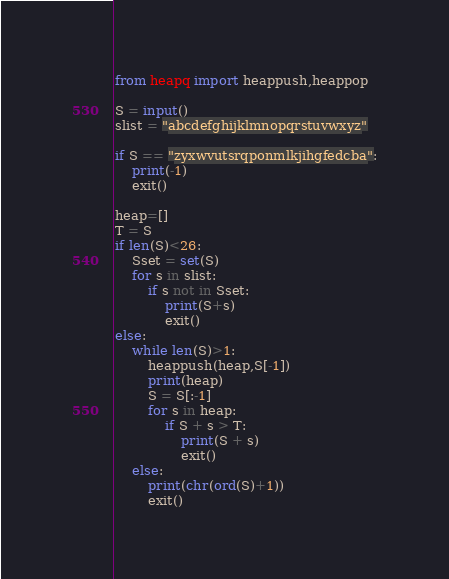Convert code to text. <code><loc_0><loc_0><loc_500><loc_500><_Python_>from heapq import heappush,heappop

S = input()
slist = "abcdefghijklmnopqrstuvwxyz"

if S == "zyxwvutsrqponmlkjihgfedcba":
    print(-1)
    exit()

heap=[]
T = S
if len(S)<26:
    Sset = set(S)
    for s in slist:
        if s not in Sset:
            print(S+s)
            exit()
else:
    while len(S)>1:
        heappush(heap,S[-1])
        print(heap)
        S = S[:-1]
        for s in heap:
            if S + s > T:
                print(S + s)
                exit()
    else:
        print(chr(ord(S)+1))
        exit()</code> 